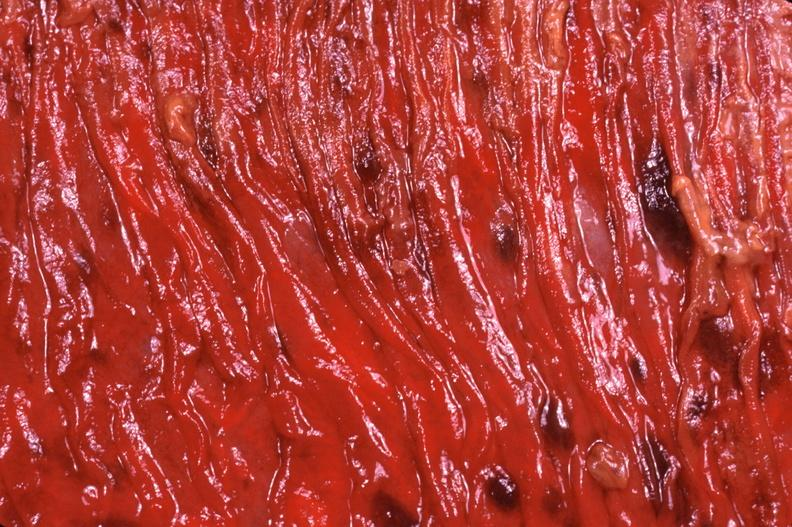s wound present?
Answer the question using a single word or phrase. No 